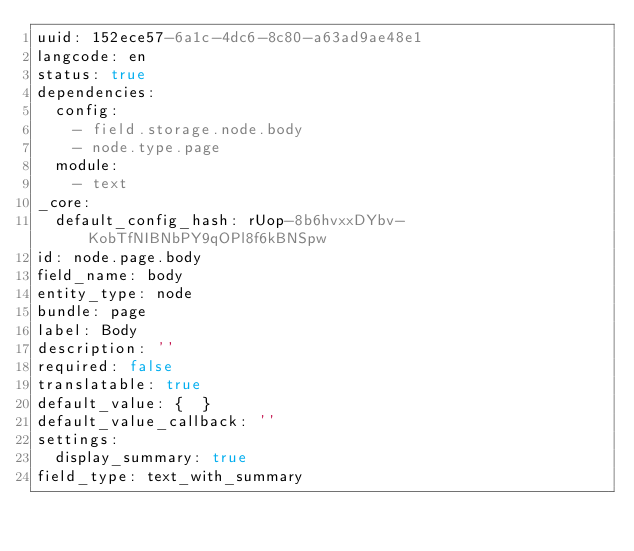Convert code to text. <code><loc_0><loc_0><loc_500><loc_500><_YAML_>uuid: 152ece57-6a1c-4dc6-8c80-a63ad9ae48e1
langcode: en
status: true
dependencies:
  config:
    - field.storage.node.body
    - node.type.page
  module:
    - text
_core:
  default_config_hash: rUop-8b6hvxxDYbv-KobTfNIBNbPY9qOPl8f6kBNSpw
id: node.page.body
field_name: body
entity_type: node
bundle: page
label: Body
description: ''
required: false
translatable: true
default_value: {  }
default_value_callback: ''
settings:
  display_summary: true
field_type: text_with_summary
</code> 